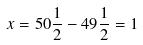<formula> <loc_0><loc_0><loc_500><loc_500>x = 5 0 \frac { 1 } { 2 } - 4 9 \frac { 1 } { 2 } = 1</formula> 